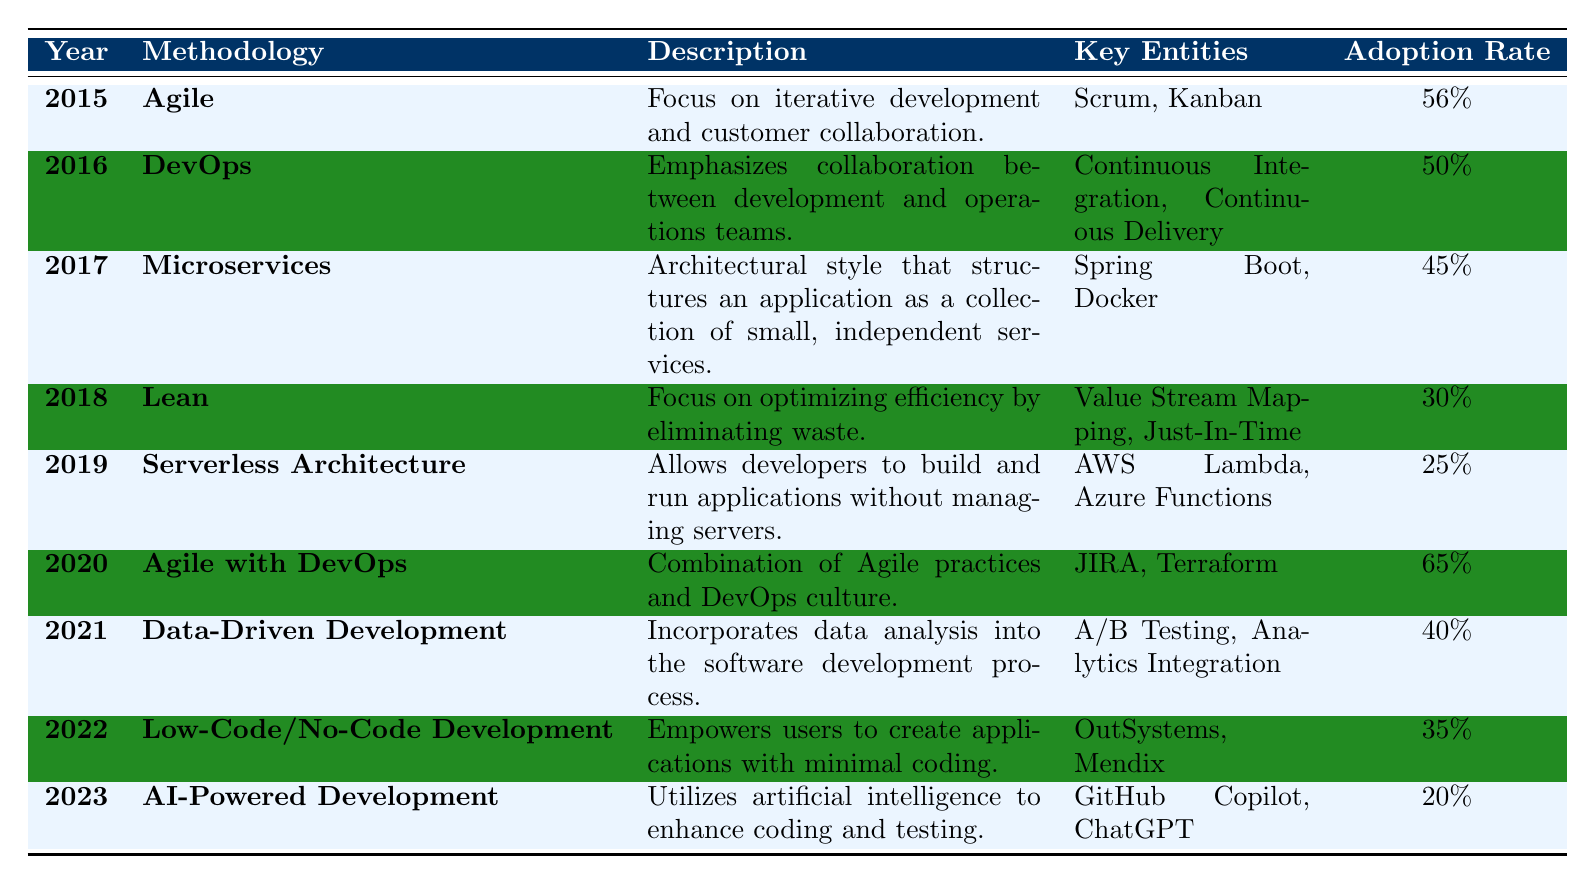What was the adoption rate of Agile in 2015? In the row for the year 2015 under the Agile methodology, the adoption rate is listed as 56%.
Answer: 56% Which methodology had the highest adoption rate and what was that rate? The methodology with the highest adoption rate is Agile with DevOps in 2020, with an adoption rate of 65%.
Answer: Agile with DevOps, 65% Is the adoption rate of Serverless Architecture higher than that of Microservices? The adoption rate for Serverless Architecture in 2019 is 25%, while Microservices in 2017 has an adoption rate of 45%. Since 45% is greater than 25%, the statement is false.
Answer: No What was the trend in adoption rates from 2015 to 2023? Looking at the adoption rates across the years, they fluctuated. Agile started at 56%, peaked at 65% in 2020, and dropped to 20% in 2023. This indicates a general downward trend after 2020.
Answer: Generally downward trend What is the average adoption rate for the methodologies listed from 2015 to 2023? To calculate the average, first list the adoption rates: 56, 50, 45, 30, 25, 65, 40, 35, 20. Summing these rates gives 366. There are 9 methodologies, so the average is 366 / 9 = 40.67.
Answer: 40.67 Which methodology saw a decline in adoption from 2019 to 2023, and what was the change in its adoption rate? Serverless Architecture had an adoption rate of 25% in 2019 and AI-Powered Development had an adoption rate of 20% in 2023. The change is a decline of 5%.
Answer: Serverless Architecture, -5% Was there ever a year in which the adoption rate decreased compared to the previous year? Yes, the adoption rate decreased from 2020 to 2021 (from 65% to 40%).
Answer: Yes What years had methodologies that focused on improvement through customer feedback and iterative processes? Agile in 2015 and Agile with DevOps in 2020 both focus on iterative development and customer collaboration.
Answer: 2015 and 2020 